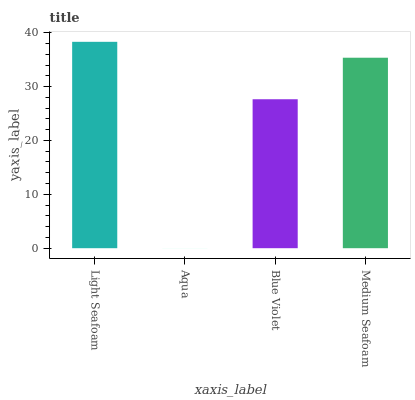Is Aqua the minimum?
Answer yes or no. Yes. Is Light Seafoam the maximum?
Answer yes or no. Yes. Is Blue Violet the minimum?
Answer yes or no. No. Is Blue Violet the maximum?
Answer yes or no. No. Is Blue Violet greater than Aqua?
Answer yes or no. Yes. Is Aqua less than Blue Violet?
Answer yes or no. Yes. Is Aqua greater than Blue Violet?
Answer yes or no. No. Is Blue Violet less than Aqua?
Answer yes or no. No. Is Medium Seafoam the high median?
Answer yes or no. Yes. Is Blue Violet the low median?
Answer yes or no. Yes. Is Light Seafoam the high median?
Answer yes or no. No. Is Medium Seafoam the low median?
Answer yes or no. No. 